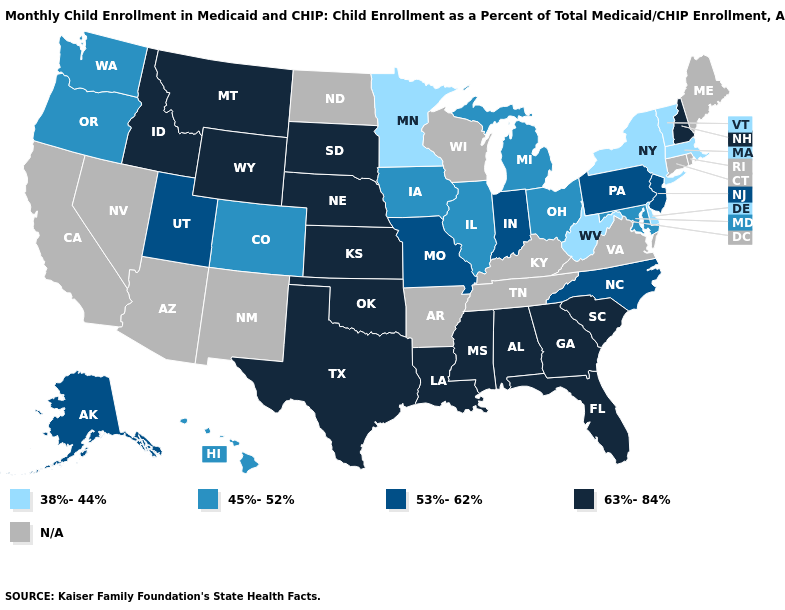What is the lowest value in the MidWest?
Give a very brief answer. 38%-44%. What is the lowest value in the USA?
Quick response, please. 38%-44%. Name the states that have a value in the range 45%-52%?
Give a very brief answer. Colorado, Hawaii, Illinois, Iowa, Maryland, Michigan, Ohio, Oregon, Washington. Name the states that have a value in the range 45%-52%?
Quick response, please. Colorado, Hawaii, Illinois, Iowa, Maryland, Michigan, Ohio, Oregon, Washington. Among the states that border Georgia , which have the lowest value?
Concise answer only. North Carolina. What is the highest value in states that border Indiana?
Give a very brief answer. 45%-52%. Name the states that have a value in the range 45%-52%?
Write a very short answer. Colorado, Hawaii, Illinois, Iowa, Maryland, Michigan, Ohio, Oregon, Washington. Does Maryland have the lowest value in the South?
Concise answer only. No. Name the states that have a value in the range 38%-44%?
Give a very brief answer. Delaware, Massachusetts, Minnesota, New York, Vermont, West Virginia. Which states have the highest value in the USA?
Answer briefly. Alabama, Florida, Georgia, Idaho, Kansas, Louisiana, Mississippi, Montana, Nebraska, New Hampshire, Oklahoma, South Carolina, South Dakota, Texas, Wyoming. What is the value of Iowa?
Concise answer only. 45%-52%. Does the first symbol in the legend represent the smallest category?
Concise answer only. Yes. Name the states that have a value in the range 38%-44%?
Give a very brief answer. Delaware, Massachusetts, Minnesota, New York, Vermont, West Virginia. Does Vermont have the lowest value in the Northeast?
Answer briefly. Yes. Which states have the lowest value in the South?
Answer briefly. Delaware, West Virginia. 